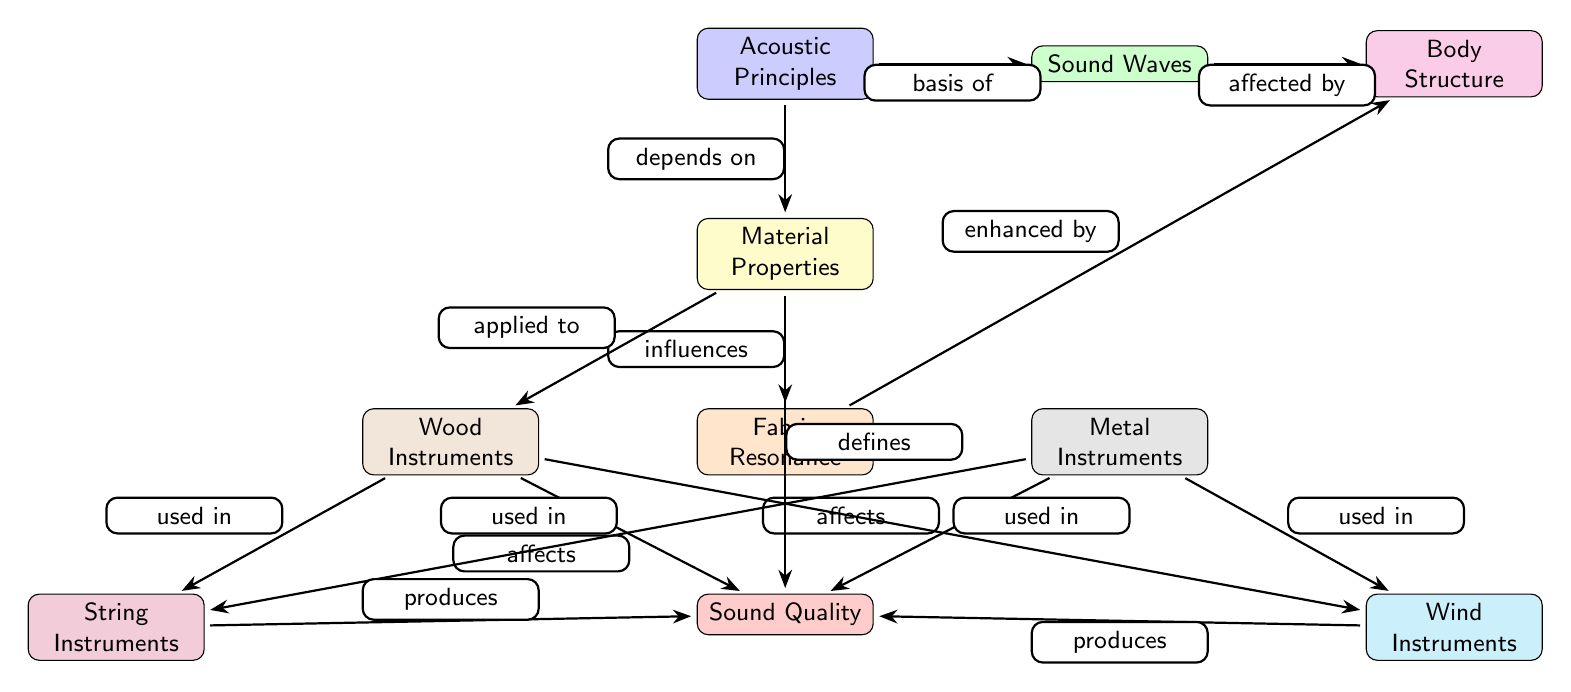What is the top node in the diagram? The top node in the diagram is "Acoustic Principles", which is the starting point for understanding the relationships illustrated in the diagram.
Answer: Acoustic Principles What color is the node representing "Wind Instruments"? The node labeled "Wind Instruments" is colored cyan, which distinguishes it from other instruments in the diagram.
Answer: Cyan How many main types of instruments are represented in the diagram? There are four main types of instruments represented in the diagram: Wood Instruments, Metal Instruments, String Instruments, and Wind Instruments. These categories are clearly displayed in the lower part of the diagram.
Answer: Four What does "Material Properties" influence? "Material Properties" influences "Fabric Resonance", which is indicated by the direct edge connecting these two nodes in the diagram.
Answer: Fabric Resonance What node is connected to both "Wood Instruments" and "Metal Instruments"? The node "Sound Quality" is connected to both "Wood Instruments" and "Metal Instruments" as they both affect the quality of sound produced, which is reflected in the edge connections in the diagram.
Answer: Sound Quality What aspect defines "Sound Quality"? "Sound Quality" is defined by "Material Properties" according to the edge indicating this relationship in the diagram.
Answer: Material Properties How many edges connect to the "Sound Waves" node? There are two edges that connect to the "Sound Waves" node, showing its relationship with "Acoustic Principles" and "Body Structure".
Answer: Two What influences "Body Structure"? The node "Sound Waves" affects "Body Structure", which is indicated by the directed edge from "Sound Waves" to "Body Structure" in the diagram.
Answer: Sound Waves Which two nodes are linked directly under "Fabric Resonance"? The two nodes directly linked under "Fabric Resonance" are "Wood Instruments" and "Metal Instruments". They both branch out from "Fabric Resonance" indicating their usage in producing sound.
Answer: Wood Instruments and Metal Instruments 